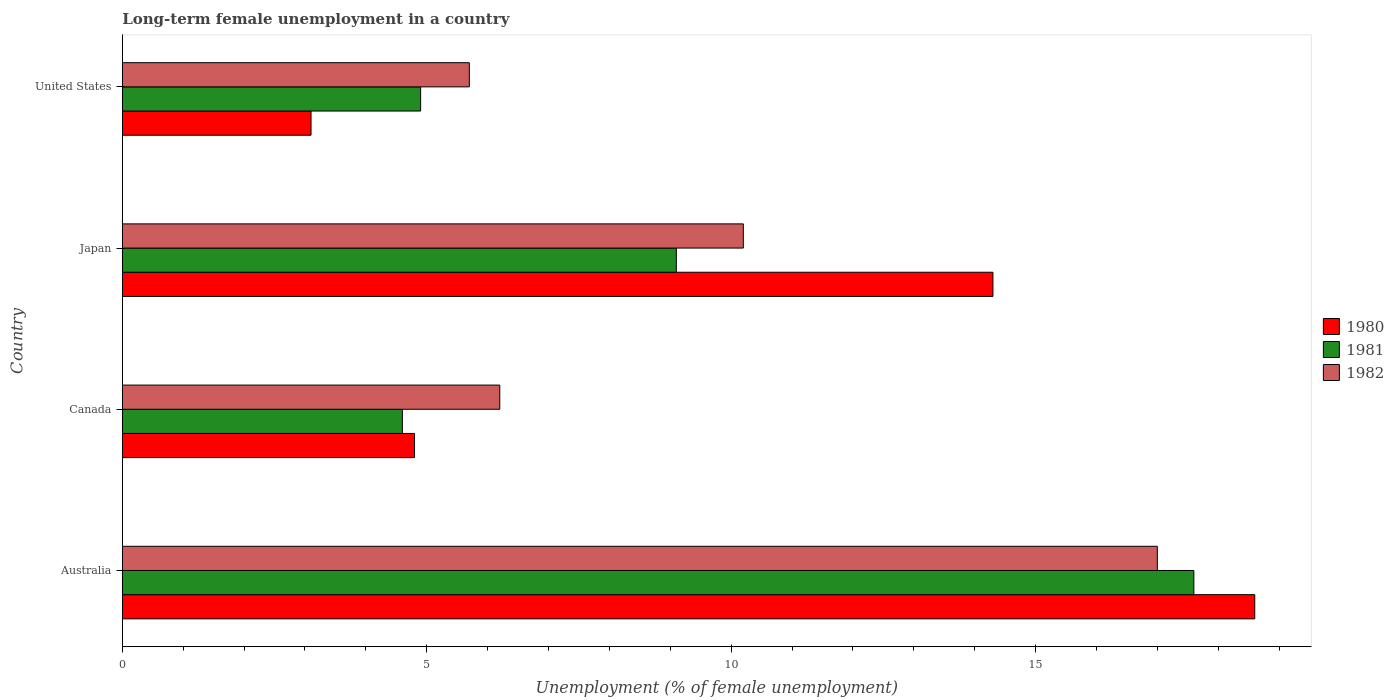How many different coloured bars are there?
Ensure brevity in your answer.  3. How many groups of bars are there?
Ensure brevity in your answer.  4. What is the label of the 1st group of bars from the top?
Your answer should be very brief. United States. In how many cases, is the number of bars for a given country not equal to the number of legend labels?
Provide a succinct answer. 0. What is the percentage of long-term unemployed female population in 1982 in Canada?
Ensure brevity in your answer.  6.2. Across all countries, what is the maximum percentage of long-term unemployed female population in 1981?
Give a very brief answer. 17.6. Across all countries, what is the minimum percentage of long-term unemployed female population in 1980?
Your answer should be very brief. 3.1. In which country was the percentage of long-term unemployed female population in 1982 minimum?
Your answer should be very brief. United States. What is the total percentage of long-term unemployed female population in 1981 in the graph?
Offer a terse response. 36.2. What is the difference between the percentage of long-term unemployed female population in 1980 in Canada and that in United States?
Provide a short and direct response. 1.7. What is the difference between the percentage of long-term unemployed female population in 1982 in Canada and the percentage of long-term unemployed female population in 1981 in Australia?
Your answer should be very brief. -11.4. What is the average percentage of long-term unemployed female population in 1981 per country?
Provide a succinct answer. 9.05. What is the difference between the percentage of long-term unemployed female population in 1982 and percentage of long-term unemployed female population in 1981 in Canada?
Offer a very short reply. 1.6. What is the ratio of the percentage of long-term unemployed female population in 1982 in Japan to that in United States?
Ensure brevity in your answer.  1.79. What is the difference between the highest and the second highest percentage of long-term unemployed female population in 1980?
Provide a succinct answer. 4.3. What is the difference between the highest and the lowest percentage of long-term unemployed female population in 1981?
Your answer should be very brief. 13. Is the sum of the percentage of long-term unemployed female population in 1982 in Canada and Japan greater than the maximum percentage of long-term unemployed female population in 1981 across all countries?
Your response must be concise. No. What does the 2nd bar from the top in Canada represents?
Offer a very short reply. 1981. Is it the case that in every country, the sum of the percentage of long-term unemployed female population in 1982 and percentage of long-term unemployed female population in 1980 is greater than the percentage of long-term unemployed female population in 1981?
Provide a short and direct response. Yes. How many countries are there in the graph?
Make the answer very short. 4. What is the difference between two consecutive major ticks on the X-axis?
Provide a short and direct response. 5. Are the values on the major ticks of X-axis written in scientific E-notation?
Give a very brief answer. No. Does the graph contain any zero values?
Provide a succinct answer. No. Does the graph contain grids?
Provide a short and direct response. No. How many legend labels are there?
Ensure brevity in your answer.  3. What is the title of the graph?
Give a very brief answer. Long-term female unemployment in a country. What is the label or title of the X-axis?
Give a very brief answer. Unemployment (% of female unemployment). What is the label or title of the Y-axis?
Provide a succinct answer. Country. What is the Unemployment (% of female unemployment) of 1980 in Australia?
Keep it short and to the point. 18.6. What is the Unemployment (% of female unemployment) in 1981 in Australia?
Your answer should be compact. 17.6. What is the Unemployment (% of female unemployment) of 1982 in Australia?
Offer a very short reply. 17. What is the Unemployment (% of female unemployment) in 1980 in Canada?
Your response must be concise. 4.8. What is the Unemployment (% of female unemployment) in 1981 in Canada?
Your answer should be very brief. 4.6. What is the Unemployment (% of female unemployment) of 1982 in Canada?
Make the answer very short. 6.2. What is the Unemployment (% of female unemployment) in 1980 in Japan?
Keep it short and to the point. 14.3. What is the Unemployment (% of female unemployment) in 1981 in Japan?
Make the answer very short. 9.1. What is the Unemployment (% of female unemployment) in 1982 in Japan?
Provide a succinct answer. 10.2. What is the Unemployment (% of female unemployment) of 1980 in United States?
Make the answer very short. 3.1. What is the Unemployment (% of female unemployment) in 1981 in United States?
Keep it short and to the point. 4.9. What is the Unemployment (% of female unemployment) in 1982 in United States?
Give a very brief answer. 5.7. Across all countries, what is the maximum Unemployment (% of female unemployment) of 1980?
Keep it short and to the point. 18.6. Across all countries, what is the maximum Unemployment (% of female unemployment) in 1981?
Keep it short and to the point. 17.6. Across all countries, what is the minimum Unemployment (% of female unemployment) of 1980?
Your answer should be very brief. 3.1. Across all countries, what is the minimum Unemployment (% of female unemployment) of 1981?
Your answer should be compact. 4.6. Across all countries, what is the minimum Unemployment (% of female unemployment) in 1982?
Provide a succinct answer. 5.7. What is the total Unemployment (% of female unemployment) of 1980 in the graph?
Your response must be concise. 40.8. What is the total Unemployment (% of female unemployment) in 1981 in the graph?
Ensure brevity in your answer.  36.2. What is the total Unemployment (% of female unemployment) in 1982 in the graph?
Ensure brevity in your answer.  39.1. What is the difference between the Unemployment (% of female unemployment) in 1980 in Australia and that in Canada?
Provide a succinct answer. 13.8. What is the difference between the Unemployment (% of female unemployment) in 1980 in Australia and that in Japan?
Your response must be concise. 4.3. What is the difference between the Unemployment (% of female unemployment) of 1980 in Australia and that in United States?
Provide a succinct answer. 15.5. What is the difference between the Unemployment (% of female unemployment) in 1981 in Australia and that in United States?
Offer a very short reply. 12.7. What is the difference between the Unemployment (% of female unemployment) of 1982 in Australia and that in United States?
Give a very brief answer. 11.3. What is the difference between the Unemployment (% of female unemployment) in 1981 in Canada and that in Japan?
Offer a terse response. -4.5. What is the difference between the Unemployment (% of female unemployment) of 1982 in Canada and that in Japan?
Provide a succinct answer. -4. What is the difference between the Unemployment (% of female unemployment) of 1980 in Canada and that in United States?
Keep it short and to the point. 1.7. What is the difference between the Unemployment (% of female unemployment) of 1981 in Canada and that in United States?
Your response must be concise. -0.3. What is the difference between the Unemployment (% of female unemployment) in 1982 in Canada and that in United States?
Your answer should be compact. 0.5. What is the difference between the Unemployment (% of female unemployment) of 1980 in Japan and that in United States?
Offer a very short reply. 11.2. What is the difference between the Unemployment (% of female unemployment) in 1981 in Japan and that in United States?
Ensure brevity in your answer.  4.2. What is the difference between the Unemployment (% of female unemployment) in 1982 in Japan and that in United States?
Ensure brevity in your answer.  4.5. What is the difference between the Unemployment (% of female unemployment) in 1980 in Australia and the Unemployment (% of female unemployment) in 1982 in Canada?
Provide a short and direct response. 12.4. What is the difference between the Unemployment (% of female unemployment) of 1981 in Australia and the Unemployment (% of female unemployment) of 1982 in Canada?
Your response must be concise. 11.4. What is the difference between the Unemployment (% of female unemployment) of 1980 in Australia and the Unemployment (% of female unemployment) of 1982 in Japan?
Ensure brevity in your answer.  8.4. What is the difference between the Unemployment (% of female unemployment) in 1981 in Australia and the Unemployment (% of female unemployment) in 1982 in Japan?
Offer a terse response. 7.4. What is the difference between the Unemployment (% of female unemployment) in 1981 in Australia and the Unemployment (% of female unemployment) in 1982 in United States?
Make the answer very short. 11.9. What is the difference between the Unemployment (% of female unemployment) of 1980 in Canada and the Unemployment (% of female unemployment) of 1981 in Japan?
Offer a very short reply. -4.3. What is the difference between the Unemployment (% of female unemployment) in 1980 in Canada and the Unemployment (% of female unemployment) in 1982 in Japan?
Your answer should be compact. -5.4. What is the difference between the Unemployment (% of female unemployment) in 1980 in Canada and the Unemployment (% of female unemployment) in 1981 in United States?
Provide a succinct answer. -0.1. What is the difference between the Unemployment (% of female unemployment) in 1981 in Canada and the Unemployment (% of female unemployment) in 1982 in United States?
Your response must be concise. -1.1. What is the difference between the Unemployment (% of female unemployment) in 1980 in Japan and the Unemployment (% of female unemployment) in 1981 in United States?
Your answer should be compact. 9.4. What is the difference between the Unemployment (% of female unemployment) of 1980 in Japan and the Unemployment (% of female unemployment) of 1982 in United States?
Give a very brief answer. 8.6. What is the average Unemployment (% of female unemployment) of 1980 per country?
Provide a short and direct response. 10.2. What is the average Unemployment (% of female unemployment) in 1981 per country?
Keep it short and to the point. 9.05. What is the average Unemployment (% of female unemployment) of 1982 per country?
Ensure brevity in your answer.  9.78. What is the difference between the Unemployment (% of female unemployment) in 1980 and Unemployment (% of female unemployment) in 1981 in Australia?
Ensure brevity in your answer.  1. What is the difference between the Unemployment (% of female unemployment) in 1980 and Unemployment (% of female unemployment) in 1982 in Australia?
Offer a terse response. 1.6. What is the difference between the Unemployment (% of female unemployment) in 1980 and Unemployment (% of female unemployment) in 1981 in Canada?
Your answer should be very brief. 0.2. What is the difference between the Unemployment (% of female unemployment) of 1980 and Unemployment (% of female unemployment) of 1982 in Canada?
Offer a terse response. -1.4. What is the difference between the Unemployment (% of female unemployment) in 1981 and Unemployment (% of female unemployment) in 1982 in Canada?
Make the answer very short. -1.6. What is the difference between the Unemployment (% of female unemployment) of 1980 and Unemployment (% of female unemployment) of 1981 in United States?
Give a very brief answer. -1.8. What is the difference between the Unemployment (% of female unemployment) in 1980 and Unemployment (% of female unemployment) in 1982 in United States?
Provide a short and direct response. -2.6. What is the difference between the Unemployment (% of female unemployment) in 1981 and Unemployment (% of female unemployment) in 1982 in United States?
Keep it short and to the point. -0.8. What is the ratio of the Unemployment (% of female unemployment) of 1980 in Australia to that in Canada?
Ensure brevity in your answer.  3.88. What is the ratio of the Unemployment (% of female unemployment) of 1981 in Australia to that in Canada?
Your response must be concise. 3.83. What is the ratio of the Unemployment (% of female unemployment) of 1982 in Australia to that in Canada?
Give a very brief answer. 2.74. What is the ratio of the Unemployment (% of female unemployment) in 1980 in Australia to that in Japan?
Give a very brief answer. 1.3. What is the ratio of the Unemployment (% of female unemployment) in 1981 in Australia to that in Japan?
Offer a terse response. 1.93. What is the ratio of the Unemployment (% of female unemployment) in 1980 in Australia to that in United States?
Provide a succinct answer. 6. What is the ratio of the Unemployment (% of female unemployment) of 1981 in Australia to that in United States?
Your response must be concise. 3.59. What is the ratio of the Unemployment (% of female unemployment) of 1982 in Australia to that in United States?
Provide a short and direct response. 2.98. What is the ratio of the Unemployment (% of female unemployment) of 1980 in Canada to that in Japan?
Ensure brevity in your answer.  0.34. What is the ratio of the Unemployment (% of female unemployment) of 1981 in Canada to that in Japan?
Offer a very short reply. 0.51. What is the ratio of the Unemployment (% of female unemployment) in 1982 in Canada to that in Japan?
Provide a succinct answer. 0.61. What is the ratio of the Unemployment (% of female unemployment) of 1980 in Canada to that in United States?
Your answer should be compact. 1.55. What is the ratio of the Unemployment (% of female unemployment) in 1981 in Canada to that in United States?
Offer a terse response. 0.94. What is the ratio of the Unemployment (% of female unemployment) in 1982 in Canada to that in United States?
Your answer should be very brief. 1.09. What is the ratio of the Unemployment (% of female unemployment) in 1980 in Japan to that in United States?
Provide a short and direct response. 4.61. What is the ratio of the Unemployment (% of female unemployment) in 1981 in Japan to that in United States?
Ensure brevity in your answer.  1.86. What is the ratio of the Unemployment (% of female unemployment) in 1982 in Japan to that in United States?
Ensure brevity in your answer.  1.79. What is the difference between the highest and the second highest Unemployment (% of female unemployment) of 1980?
Provide a short and direct response. 4.3. What is the difference between the highest and the lowest Unemployment (% of female unemployment) in 1982?
Give a very brief answer. 11.3. 